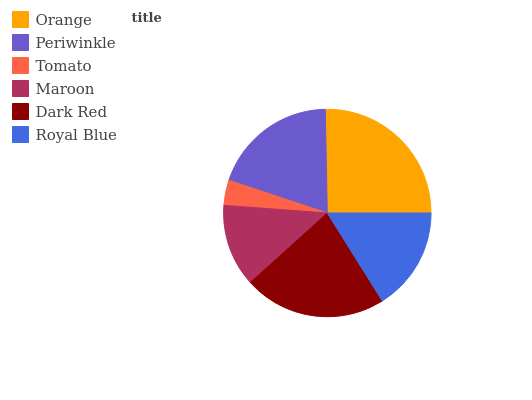Is Tomato the minimum?
Answer yes or no. Yes. Is Orange the maximum?
Answer yes or no. Yes. Is Periwinkle the minimum?
Answer yes or no. No. Is Periwinkle the maximum?
Answer yes or no. No. Is Orange greater than Periwinkle?
Answer yes or no. Yes. Is Periwinkle less than Orange?
Answer yes or no. Yes. Is Periwinkle greater than Orange?
Answer yes or no. No. Is Orange less than Periwinkle?
Answer yes or no. No. Is Periwinkle the high median?
Answer yes or no. Yes. Is Royal Blue the low median?
Answer yes or no. Yes. Is Maroon the high median?
Answer yes or no. No. Is Tomato the low median?
Answer yes or no. No. 